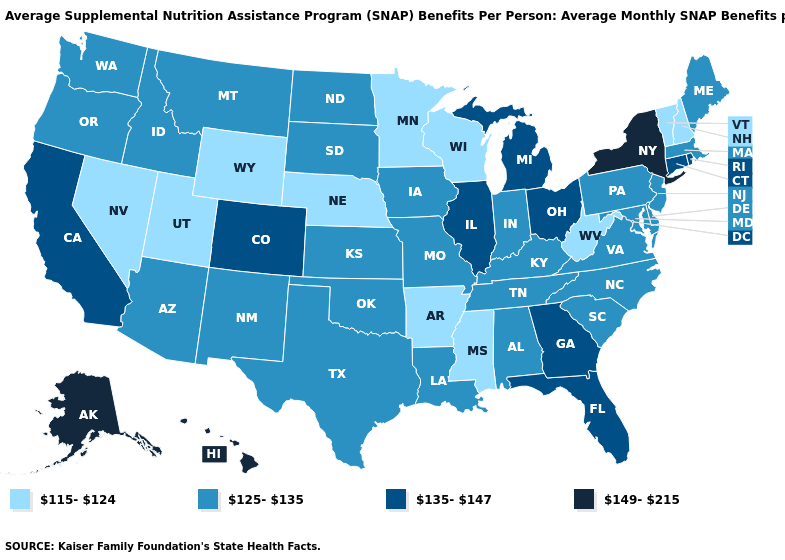Does the first symbol in the legend represent the smallest category?
Keep it brief. Yes. Name the states that have a value in the range 125-135?
Short answer required. Alabama, Arizona, Delaware, Idaho, Indiana, Iowa, Kansas, Kentucky, Louisiana, Maine, Maryland, Massachusetts, Missouri, Montana, New Jersey, New Mexico, North Carolina, North Dakota, Oklahoma, Oregon, Pennsylvania, South Carolina, South Dakota, Tennessee, Texas, Virginia, Washington. Does the first symbol in the legend represent the smallest category?
Give a very brief answer. Yes. Does Delaware have the lowest value in the South?
Short answer required. No. What is the lowest value in states that border Iowa?
Keep it brief. 115-124. Name the states that have a value in the range 125-135?
Quick response, please. Alabama, Arizona, Delaware, Idaho, Indiana, Iowa, Kansas, Kentucky, Louisiana, Maine, Maryland, Massachusetts, Missouri, Montana, New Jersey, New Mexico, North Carolina, North Dakota, Oklahoma, Oregon, Pennsylvania, South Carolina, South Dakota, Tennessee, Texas, Virginia, Washington. Name the states that have a value in the range 135-147?
Short answer required. California, Colorado, Connecticut, Florida, Georgia, Illinois, Michigan, Ohio, Rhode Island. Among the states that border Michigan , does Ohio have the lowest value?
Be succinct. No. Does Rhode Island have a lower value than Massachusetts?
Concise answer only. No. Does Utah have the lowest value in the USA?
Answer briefly. Yes. Among the states that border Tennessee , which have the highest value?
Give a very brief answer. Georgia. Which states hav the highest value in the West?
Keep it brief. Alaska, Hawaii. Does Alabama have a lower value than Georgia?
Give a very brief answer. No. Does South Carolina have a lower value than Vermont?
Answer briefly. No. Among the states that border North Carolina , which have the lowest value?
Concise answer only. South Carolina, Tennessee, Virginia. 